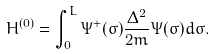<formula> <loc_0><loc_0><loc_500><loc_500>H ^ { ( 0 ) } = \int _ { 0 } ^ { L } \Psi ^ { + } ( \sigma ) \frac { \Delta ^ { 2 } } { 2 m } \Psi ( \sigma ) d \sigma .</formula> 